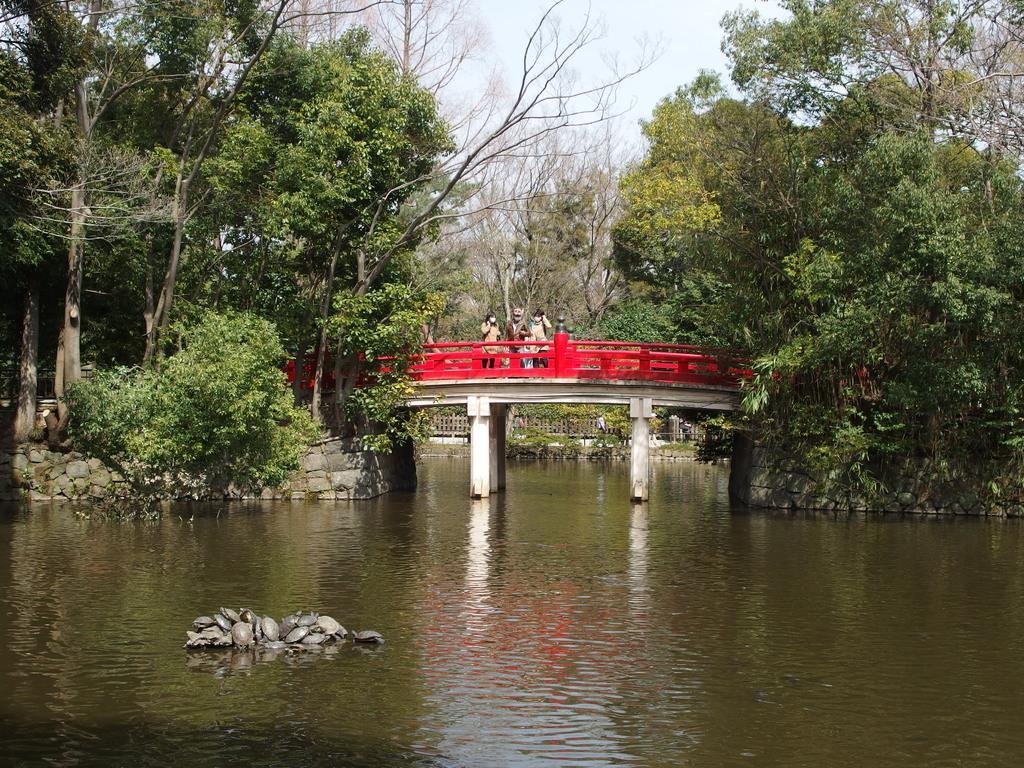In one or two sentences, can you explain what this image depicts? In this image on the foreground there is water body. In the background there are trees, stones, fence, bridge. On the bridge there are few people. 